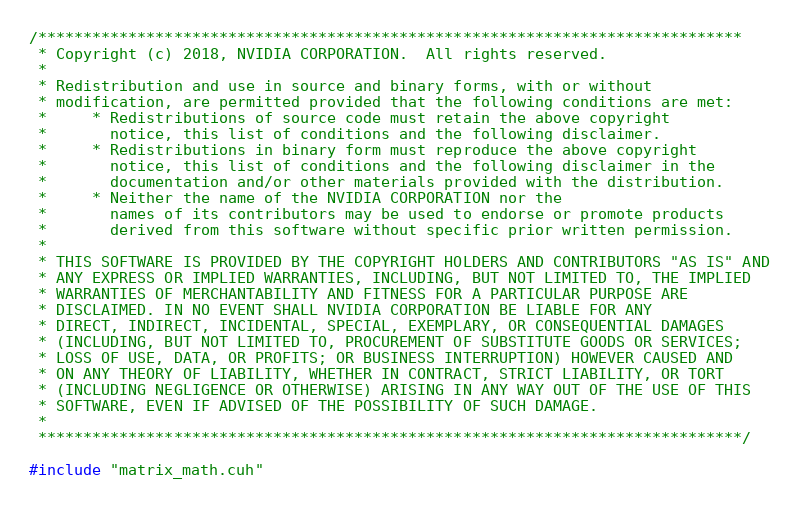<code> <loc_0><loc_0><loc_500><loc_500><_Cuda_>/******************************************************************************
 * Copyright (c) 2018, NVIDIA CORPORATION.  All rights reserved.
 *
 * Redistribution and use in source and binary forms, with or without
 * modification, are permitted provided that the following conditions are met:
 *     * Redistributions of source code must retain the above copyright
 *       notice, this list of conditions and the following disclaimer.
 *     * Redistributions in binary form must reproduce the above copyright
 *       notice, this list of conditions and the following disclaimer in the
 *       documentation and/or other materials provided with the distribution.
 *     * Neither the name of the NVIDIA CORPORATION nor the
 *       names of its contributors may be used to endorse or promote products
 *       derived from this software without specific prior written permission.
 *
 * THIS SOFTWARE IS PROVIDED BY THE COPYRIGHT HOLDERS AND CONTRIBUTORS "AS IS" AND
 * ANY EXPRESS OR IMPLIED WARRANTIES, INCLUDING, BUT NOT LIMITED TO, THE IMPLIED
 * WARRANTIES OF MERCHANTABILITY AND FITNESS FOR A PARTICULAR PURPOSE ARE
 * DISCLAIMED. IN NO EVENT SHALL NVIDIA CORPORATION BE LIABLE FOR ANY
 * DIRECT, INDIRECT, INCIDENTAL, SPECIAL, EXEMPLARY, OR CONSEQUENTIAL DAMAGES
 * (INCLUDING, BUT NOT LIMITED TO, PROCUREMENT OF SUBSTITUTE GOODS OR SERVICES;
 * LOSS OF USE, DATA, OR PROFITS; OR BUSINESS INTERRUPTION) HOWEVER CAUSED AND
 * ON ANY THEORY OF LIABILITY, WHETHER IN CONTRACT, STRICT LIABILITY, OR TORT
 * (INCLUDING NEGLIGENCE OR OTHERWISE) ARISING IN ANY WAY OUT OF THE USE OF THIS
 * SOFTWARE, EVEN IF ADVISED OF THE POSSIBILITY OF SUCH DAMAGE.
 *
 ******************************************************************************/

#include "matrix_math.cuh"</code> 